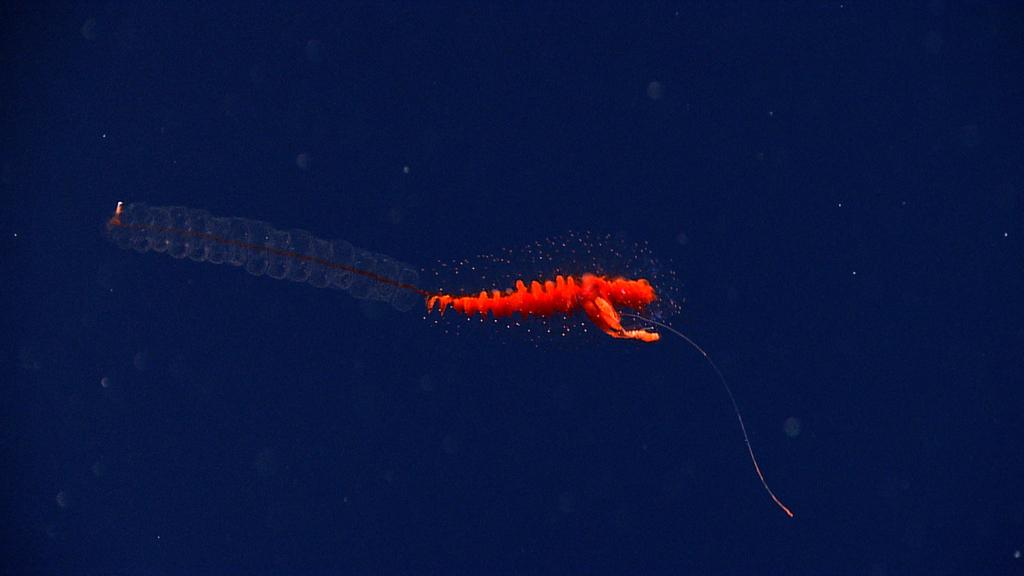What type of animal is in the image? There is a red-colored invertebrate in the image. Can you describe the appearance of the invertebrate? The invertebrate resembles an aquatic animal. What type of pleasure can be seen being experienced by the invertebrate in the image? There is no indication in the image that the invertebrate is experiencing any pleasure, as it is an inanimate object. 